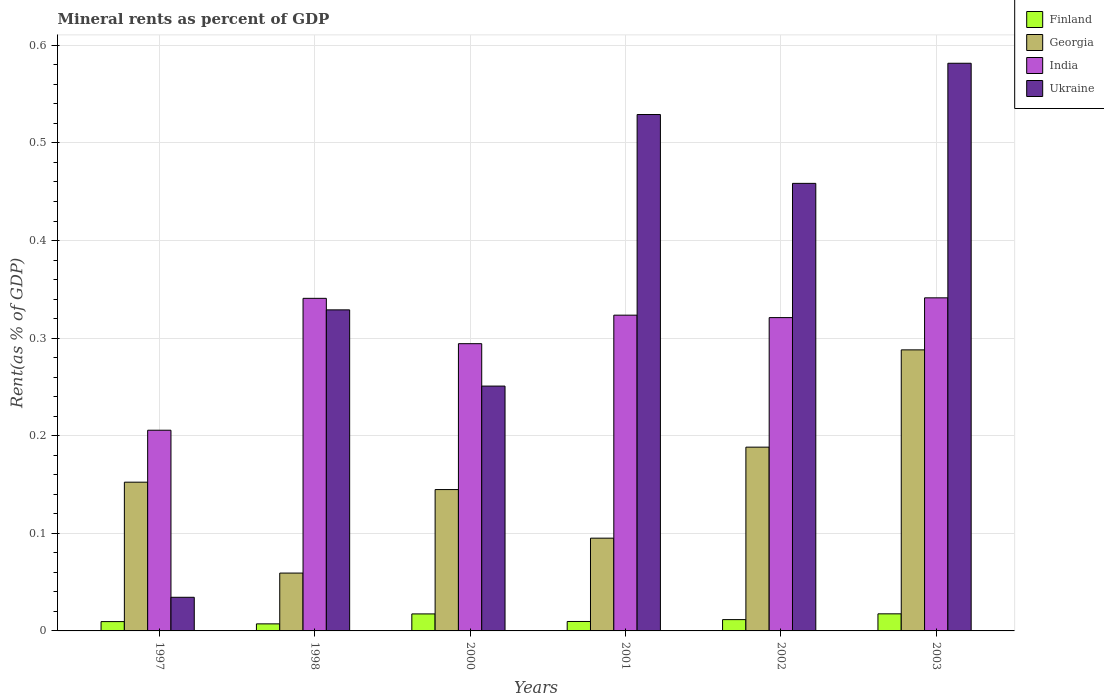How many different coloured bars are there?
Offer a very short reply. 4. How many groups of bars are there?
Give a very brief answer. 6. Are the number of bars per tick equal to the number of legend labels?
Give a very brief answer. Yes. Are the number of bars on each tick of the X-axis equal?
Offer a terse response. Yes. How many bars are there on the 1st tick from the right?
Offer a very short reply. 4. What is the label of the 6th group of bars from the left?
Provide a short and direct response. 2003. In how many cases, is the number of bars for a given year not equal to the number of legend labels?
Provide a short and direct response. 0. What is the mineral rent in Ukraine in 2001?
Your answer should be very brief. 0.53. Across all years, what is the maximum mineral rent in Finland?
Your response must be concise. 0.02. Across all years, what is the minimum mineral rent in Finland?
Your answer should be very brief. 0.01. In which year was the mineral rent in Georgia minimum?
Make the answer very short. 1998. What is the total mineral rent in Georgia in the graph?
Keep it short and to the point. 0.93. What is the difference between the mineral rent in Finland in 2000 and that in 2003?
Your answer should be very brief. -7.728622629299756e-5. What is the difference between the mineral rent in India in 1997 and the mineral rent in Finland in 2001?
Offer a terse response. 0.2. What is the average mineral rent in Georgia per year?
Give a very brief answer. 0.15. In the year 2001, what is the difference between the mineral rent in India and mineral rent in Georgia?
Offer a terse response. 0.23. What is the ratio of the mineral rent in India in 1998 to that in 2001?
Provide a succinct answer. 1.05. What is the difference between the highest and the second highest mineral rent in Georgia?
Offer a very short reply. 0.1. What is the difference between the highest and the lowest mineral rent in Georgia?
Offer a terse response. 0.23. In how many years, is the mineral rent in India greater than the average mineral rent in India taken over all years?
Give a very brief answer. 4. Is it the case that in every year, the sum of the mineral rent in Georgia and mineral rent in Ukraine is greater than the sum of mineral rent in Finland and mineral rent in India?
Your response must be concise. No. What does the 4th bar from the left in 2000 represents?
Your answer should be very brief. Ukraine. What does the 1st bar from the right in 2002 represents?
Provide a short and direct response. Ukraine. Is it the case that in every year, the sum of the mineral rent in Ukraine and mineral rent in Finland is greater than the mineral rent in India?
Your response must be concise. No. How many bars are there?
Make the answer very short. 24. How many years are there in the graph?
Provide a succinct answer. 6. Does the graph contain any zero values?
Offer a terse response. No. Where does the legend appear in the graph?
Offer a very short reply. Top right. How many legend labels are there?
Your answer should be very brief. 4. What is the title of the graph?
Your response must be concise. Mineral rents as percent of GDP. Does "Angola" appear as one of the legend labels in the graph?
Offer a very short reply. No. What is the label or title of the Y-axis?
Give a very brief answer. Rent(as % of GDP). What is the Rent(as % of GDP) of Finland in 1997?
Ensure brevity in your answer.  0.01. What is the Rent(as % of GDP) of Georgia in 1997?
Provide a succinct answer. 0.15. What is the Rent(as % of GDP) in India in 1997?
Provide a short and direct response. 0.21. What is the Rent(as % of GDP) in Ukraine in 1997?
Offer a very short reply. 0.03. What is the Rent(as % of GDP) in Finland in 1998?
Ensure brevity in your answer.  0.01. What is the Rent(as % of GDP) in Georgia in 1998?
Keep it short and to the point. 0.06. What is the Rent(as % of GDP) of India in 1998?
Provide a short and direct response. 0.34. What is the Rent(as % of GDP) in Ukraine in 1998?
Give a very brief answer. 0.33. What is the Rent(as % of GDP) in Finland in 2000?
Provide a succinct answer. 0.02. What is the Rent(as % of GDP) of Georgia in 2000?
Offer a terse response. 0.14. What is the Rent(as % of GDP) in India in 2000?
Offer a very short reply. 0.29. What is the Rent(as % of GDP) in Ukraine in 2000?
Offer a terse response. 0.25. What is the Rent(as % of GDP) in Finland in 2001?
Ensure brevity in your answer.  0.01. What is the Rent(as % of GDP) of Georgia in 2001?
Make the answer very short. 0.1. What is the Rent(as % of GDP) of India in 2001?
Your response must be concise. 0.32. What is the Rent(as % of GDP) of Ukraine in 2001?
Offer a very short reply. 0.53. What is the Rent(as % of GDP) in Finland in 2002?
Provide a short and direct response. 0.01. What is the Rent(as % of GDP) in Georgia in 2002?
Ensure brevity in your answer.  0.19. What is the Rent(as % of GDP) of India in 2002?
Give a very brief answer. 0.32. What is the Rent(as % of GDP) of Ukraine in 2002?
Your answer should be very brief. 0.46. What is the Rent(as % of GDP) of Finland in 2003?
Provide a succinct answer. 0.02. What is the Rent(as % of GDP) of Georgia in 2003?
Offer a terse response. 0.29. What is the Rent(as % of GDP) in India in 2003?
Provide a short and direct response. 0.34. What is the Rent(as % of GDP) in Ukraine in 2003?
Ensure brevity in your answer.  0.58. Across all years, what is the maximum Rent(as % of GDP) of Finland?
Provide a short and direct response. 0.02. Across all years, what is the maximum Rent(as % of GDP) of Georgia?
Make the answer very short. 0.29. Across all years, what is the maximum Rent(as % of GDP) of India?
Provide a short and direct response. 0.34. Across all years, what is the maximum Rent(as % of GDP) of Ukraine?
Offer a very short reply. 0.58. Across all years, what is the minimum Rent(as % of GDP) of Finland?
Provide a short and direct response. 0.01. Across all years, what is the minimum Rent(as % of GDP) of Georgia?
Your response must be concise. 0.06. Across all years, what is the minimum Rent(as % of GDP) of India?
Keep it short and to the point. 0.21. Across all years, what is the minimum Rent(as % of GDP) in Ukraine?
Keep it short and to the point. 0.03. What is the total Rent(as % of GDP) in Finland in the graph?
Ensure brevity in your answer.  0.07. What is the total Rent(as % of GDP) of Georgia in the graph?
Give a very brief answer. 0.93. What is the total Rent(as % of GDP) of India in the graph?
Your response must be concise. 1.83. What is the total Rent(as % of GDP) of Ukraine in the graph?
Ensure brevity in your answer.  2.18. What is the difference between the Rent(as % of GDP) of Finland in 1997 and that in 1998?
Offer a terse response. 0. What is the difference between the Rent(as % of GDP) of Georgia in 1997 and that in 1998?
Offer a very short reply. 0.09. What is the difference between the Rent(as % of GDP) in India in 1997 and that in 1998?
Your answer should be very brief. -0.14. What is the difference between the Rent(as % of GDP) of Ukraine in 1997 and that in 1998?
Give a very brief answer. -0.29. What is the difference between the Rent(as % of GDP) in Finland in 1997 and that in 2000?
Your answer should be very brief. -0.01. What is the difference between the Rent(as % of GDP) of Georgia in 1997 and that in 2000?
Your answer should be very brief. 0.01. What is the difference between the Rent(as % of GDP) of India in 1997 and that in 2000?
Ensure brevity in your answer.  -0.09. What is the difference between the Rent(as % of GDP) in Ukraine in 1997 and that in 2000?
Provide a short and direct response. -0.22. What is the difference between the Rent(as % of GDP) of Finland in 1997 and that in 2001?
Offer a very short reply. -0. What is the difference between the Rent(as % of GDP) of Georgia in 1997 and that in 2001?
Provide a short and direct response. 0.06. What is the difference between the Rent(as % of GDP) in India in 1997 and that in 2001?
Make the answer very short. -0.12. What is the difference between the Rent(as % of GDP) in Ukraine in 1997 and that in 2001?
Give a very brief answer. -0.49. What is the difference between the Rent(as % of GDP) in Finland in 1997 and that in 2002?
Your answer should be very brief. -0. What is the difference between the Rent(as % of GDP) of Georgia in 1997 and that in 2002?
Ensure brevity in your answer.  -0.04. What is the difference between the Rent(as % of GDP) in India in 1997 and that in 2002?
Offer a very short reply. -0.12. What is the difference between the Rent(as % of GDP) of Ukraine in 1997 and that in 2002?
Your answer should be very brief. -0.42. What is the difference between the Rent(as % of GDP) in Finland in 1997 and that in 2003?
Your answer should be compact. -0.01. What is the difference between the Rent(as % of GDP) of Georgia in 1997 and that in 2003?
Your response must be concise. -0.14. What is the difference between the Rent(as % of GDP) of India in 1997 and that in 2003?
Your answer should be compact. -0.14. What is the difference between the Rent(as % of GDP) in Ukraine in 1997 and that in 2003?
Offer a very short reply. -0.55. What is the difference between the Rent(as % of GDP) in Finland in 1998 and that in 2000?
Your response must be concise. -0.01. What is the difference between the Rent(as % of GDP) of Georgia in 1998 and that in 2000?
Your answer should be very brief. -0.09. What is the difference between the Rent(as % of GDP) in India in 1998 and that in 2000?
Your response must be concise. 0.05. What is the difference between the Rent(as % of GDP) in Ukraine in 1998 and that in 2000?
Your response must be concise. 0.08. What is the difference between the Rent(as % of GDP) in Finland in 1998 and that in 2001?
Ensure brevity in your answer.  -0. What is the difference between the Rent(as % of GDP) of Georgia in 1998 and that in 2001?
Provide a succinct answer. -0.04. What is the difference between the Rent(as % of GDP) in India in 1998 and that in 2001?
Provide a succinct answer. 0.02. What is the difference between the Rent(as % of GDP) of Ukraine in 1998 and that in 2001?
Your answer should be compact. -0.2. What is the difference between the Rent(as % of GDP) in Finland in 1998 and that in 2002?
Offer a terse response. -0. What is the difference between the Rent(as % of GDP) in Georgia in 1998 and that in 2002?
Provide a short and direct response. -0.13. What is the difference between the Rent(as % of GDP) of India in 1998 and that in 2002?
Your answer should be compact. 0.02. What is the difference between the Rent(as % of GDP) of Ukraine in 1998 and that in 2002?
Ensure brevity in your answer.  -0.13. What is the difference between the Rent(as % of GDP) in Finland in 1998 and that in 2003?
Keep it short and to the point. -0.01. What is the difference between the Rent(as % of GDP) in Georgia in 1998 and that in 2003?
Your response must be concise. -0.23. What is the difference between the Rent(as % of GDP) of India in 1998 and that in 2003?
Ensure brevity in your answer.  -0. What is the difference between the Rent(as % of GDP) of Ukraine in 1998 and that in 2003?
Ensure brevity in your answer.  -0.25. What is the difference between the Rent(as % of GDP) of Finland in 2000 and that in 2001?
Your answer should be compact. 0.01. What is the difference between the Rent(as % of GDP) of Georgia in 2000 and that in 2001?
Provide a short and direct response. 0.05. What is the difference between the Rent(as % of GDP) in India in 2000 and that in 2001?
Your answer should be very brief. -0.03. What is the difference between the Rent(as % of GDP) of Ukraine in 2000 and that in 2001?
Your response must be concise. -0.28. What is the difference between the Rent(as % of GDP) of Finland in 2000 and that in 2002?
Your answer should be very brief. 0.01. What is the difference between the Rent(as % of GDP) in Georgia in 2000 and that in 2002?
Keep it short and to the point. -0.04. What is the difference between the Rent(as % of GDP) in India in 2000 and that in 2002?
Keep it short and to the point. -0.03. What is the difference between the Rent(as % of GDP) in Ukraine in 2000 and that in 2002?
Your answer should be very brief. -0.21. What is the difference between the Rent(as % of GDP) in Finland in 2000 and that in 2003?
Keep it short and to the point. -0. What is the difference between the Rent(as % of GDP) in Georgia in 2000 and that in 2003?
Give a very brief answer. -0.14. What is the difference between the Rent(as % of GDP) of India in 2000 and that in 2003?
Provide a succinct answer. -0.05. What is the difference between the Rent(as % of GDP) in Ukraine in 2000 and that in 2003?
Make the answer very short. -0.33. What is the difference between the Rent(as % of GDP) of Finland in 2001 and that in 2002?
Give a very brief answer. -0. What is the difference between the Rent(as % of GDP) in Georgia in 2001 and that in 2002?
Provide a short and direct response. -0.09. What is the difference between the Rent(as % of GDP) in India in 2001 and that in 2002?
Give a very brief answer. 0. What is the difference between the Rent(as % of GDP) of Ukraine in 2001 and that in 2002?
Your answer should be compact. 0.07. What is the difference between the Rent(as % of GDP) in Finland in 2001 and that in 2003?
Provide a short and direct response. -0.01. What is the difference between the Rent(as % of GDP) in Georgia in 2001 and that in 2003?
Keep it short and to the point. -0.19. What is the difference between the Rent(as % of GDP) of India in 2001 and that in 2003?
Your answer should be compact. -0.02. What is the difference between the Rent(as % of GDP) of Ukraine in 2001 and that in 2003?
Offer a terse response. -0.05. What is the difference between the Rent(as % of GDP) in Finland in 2002 and that in 2003?
Your answer should be compact. -0.01. What is the difference between the Rent(as % of GDP) of Georgia in 2002 and that in 2003?
Offer a very short reply. -0.1. What is the difference between the Rent(as % of GDP) in India in 2002 and that in 2003?
Your answer should be very brief. -0.02. What is the difference between the Rent(as % of GDP) in Ukraine in 2002 and that in 2003?
Your response must be concise. -0.12. What is the difference between the Rent(as % of GDP) in Finland in 1997 and the Rent(as % of GDP) in Georgia in 1998?
Make the answer very short. -0.05. What is the difference between the Rent(as % of GDP) in Finland in 1997 and the Rent(as % of GDP) in India in 1998?
Give a very brief answer. -0.33. What is the difference between the Rent(as % of GDP) of Finland in 1997 and the Rent(as % of GDP) of Ukraine in 1998?
Offer a terse response. -0.32. What is the difference between the Rent(as % of GDP) in Georgia in 1997 and the Rent(as % of GDP) in India in 1998?
Give a very brief answer. -0.19. What is the difference between the Rent(as % of GDP) in Georgia in 1997 and the Rent(as % of GDP) in Ukraine in 1998?
Your answer should be very brief. -0.18. What is the difference between the Rent(as % of GDP) of India in 1997 and the Rent(as % of GDP) of Ukraine in 1998?
Provide a succinct answer. -0.12. What is the difference between the Rent(as % of GDP) of Finland in 1997 and the Rent(as % of GDP) of Georgia in 2000?
Give a very brief answer. -0.14. What is the difference between the Rent(as % of GDP) of Finland in 1997 and the Rent(as % of GDP) of India in 2000?
Provide a short and direct response. -0.28. What is the difference between the Rent(as % of GDP) of Finland in 1997 and the Rent(as % of GDP) of Ukraine in 2000?
Offer a terse response. -0.24. What is the difference between the Rent(as % of GDP) in Georgia in 1997 and the Rent(as % of GDP) in India in 2000?
Provide a succinct answer. -0.14. What is the difference between the Rent(as % of GDP) in Georgia in 1997 and the Rent(as % of GDP) in Ukraine in 2000?
Your answer should be very brief. -0.1. What is the difference between the Rent(as % of GDP) in India in 1997 and the Rent(as % of GDP) in Ukraine in 2000?
Keep it short and to the point. -0.05. What is the difference between the Rent(as % of GDP) of Finland in 1997 and the Rent(as % of GDP) of Georgia in 2001?
Provide a short and direct response. -0.09. What is the difference between the Rent(as % of GDP) of Finland in 1997 and the Rent(as % of GDP) of India in 2001?
Offer a terse response. -0.31. What is the difference between the Rent(as % of GDP) in Finland in 1997 and the Rent(as % of GDP) in Ukraine in 2001?
Your response must be concise. -0.52. What is the difference between the Rent(as % of GDP) in Georgia in 1997 and the Rent(as % of GDP) in India in 2001?
Your answer should be compact. -0.17. What is the difference between the Rent(as % of GDP) in Georgia in 1997 and the Rent(as % of GDP) in Ukraine in 2001?
Ensure brevity in your answer.  -0.38. What is the difference between the Rent(as % of GDP) of India in 1997 and the Rent(as % of GDP) of Ukraine in 2001?
Your response must be concise. -0.32. What is the difference between the Rent(as % of GDP) of Finland in 1997 and the Rent(as % of GDP) of Georgia in 2002?
Offer a terse response. -0.18. What is the difference between the Rent(as % of GDP) in Finland in 1997 and the Rent(as % of GDP) in India in 2002?
Your answer should be compact. -0.31. What is the difference between the Rent(as % of GDP) of Finland in 1997 and the Rent(as % of GDP) of Ukraine in 2002?
Make the answer very short. -0.45. What is the difference between the Rent(as % of GDP) of Georgia in 1997 and the Rent(as % of GDP) of India in 2002?
Make the answer very short. -0.17. What is the difference between the Rent(as % of GDP) in Georgia in 1997 and the Rent(as % of GDP) in Ukraine in 2002?
Offer a terse response. -0.31. What is the difference between the Rent(as % of GDP) in India in 1997 and the Rent(as % of GDP) in Ukraine in 2002?
Provide a short and direct response. -0.25. What is the difference between the Rent(as % of GDP) in Finland in 1997 and the Rent(as % of GDP) in Georgia in 2003?
Your response must be concise. -0.28. What is the difference between the Rent(as % of GDP) of Finland in 1997 and the Rent(as % of GDP) of India in 2003?
Ensure brevity in your answer.  -0.33. What is the difference between the Rent(as % of GDP) in Finland in 1997 and the Rent(as % of GDP) in Ukraine in 2003?
Keep it short and to the point. -0.57. What is the difference between the Rent(as % of GDP) of Georgia in 1997 and the Rent(as % of GDP) of India in 2003?
Ensure brevity in your answer.  -0.19. What is the difference between the Rent(as % of GDP) of Georgia in 1997 and the Rent(as % of GDP) of Ukraine in 2003?
Make the answer very short. -0.43. What is the difference between the Rent(as % of GDP) in India in 1997 and the Rent(as % of GDP) in Ukraine in 2003?
Make the answer very short. -0.38. What is the difference between the Rent(as % of GDP) of Finland in 1998 and the Rent(as % of GDP) of Georgia in 2000?
Offer a terse response. -0.14. What is the difference between the Rent(as % of GDP) in Finland in 1998 and the Rent(as % of GDP) in India in 2000?
Provide a succinct answer. -0.29. What is the difference between the Rent(as % of GDP) in Finland in 1998 and the Rent(as % of GDP) in Ukraine in 2000?
Make the answer very short. -0.24. What is the difference between the Rent(as % of GDP) in Georgia in 1998 and the Rent(as % of GDP) in India in 2000?
Offer a terse response. -0.23. What is the difference between the Rent(as % of GDP) of Georgia in 1998 and the Rent(as % of GDP) of Ukraine in 2000?
Your answer should be compact. -0.19. What is the difference between the Rent(as % of GDP) in India in 1998 and the Rent(as % of GDP) in Ukraine in 2000?
Your answer should be compact. 0.09. What is the difference between the Rent(as % of GDP) of Finland in 1998 and the Rent(as % of GDP) of Georgia in 2001?
Your response must be concise. -0.09. What is the difference between the Rent(as % of GDP) in Finland in 1998 and the Rent(as % of GDP) in India in 2001?
Provide a succinct answer. -0.32. What is the difference between the Rent(as % of GDP) in Finland in 1998 and the Rent(as % of GDP) in Ukraine in 2001?
Your response must be concise. -0.52. What is the difference between the Rent(as % of GDP) in Georgia in 1998 and the Rent(as % of GDP) in India in 2001?
Ensure brevity in your answer.  -0.26. What is the difference between the Rent(as % of GDP) of Georgia in 1998 and the Rent(as % of GDP) of Ukraine in 2001?
Offer a very short reply. -0.47. What is the difference between the Rent(as % of GDP) of India in 1998 and the Rent(as % of GDP) of Ukraine in 2001?
Offer a very short reply. -0.19. What is the difference between the Rent(as % of GDP) of Finland in 1998 and the Rent(as % of GDP) of Georgia in 2002?
Your response must be concise. -0.18. What is the difference between the Rent(as % of GDP) in Finland in 1998 and the Rent(as % of GDP) in India in 2002?
Your answer should be very brief. -0.31. What is the difference between the Rent(as % of GDP) in Finland in 1998 and the Rent(as % of GDP) in Ukraine in 2002?
Provide a short and direct response. -0.45. What is the difference between the Rent(as % of GDP) of Georgia in 1998 and the Rent(as % of GDP) of India in 2002?
Your answer should be very brief. -0.26. What is the difference between the Rent(as % of GDP) of Georgia in 1998 and the Rent(as % of GDP) of Ukraine in 2002?
Provide a succinct answer. -0.4. What is the difference between the Rent(as % of GDP) of India in 1998 and the Rent(as % of GDP) of Ukraine in 2002?
Your answer should be very brief. -0.12. What is the difference between the Rent(as % of GDP) in Finland in 1998 and the Rent(as % of GDP) in Georgia in 2003?
Ensure brevity in your answer.  -0.28. What is the difference between the Rent(as % of GDP) in Finland in 1998 and the Rent(as % of GDP) in India in 2003?
Provide a succinct answer. -0.33. What is the difference between the Rent(as % of GDP) in Finland in 1998 and the Rent(as % of GDP) in Ukraine in 2003?
Offer a terse response. -0.57. What is the difference between the Rent(as % of GDP) in Georgia in 1998 and the Rent(as % of GDP) in India in 2003?
Provide a short and direct response. -0.28. What is the difference between the Rent(as % of GDP) in Georgia in 1998 and the Rent(as % of GDP) in Ukraine in 2003?
Your answer should be compact. -0.52. What is the difference between the Rent(as % of GDP) of India in 1998 and the Rent(as % of GDP) of Ukraine in 2003?
Ensure brevity in your answer.  -0.24. What is the difference between the Rent(as % of GDP) of Finland in 2000 and the Rent(as % of GDP) of Georgia in 2001?
Provide a short and direct response. -0.08. What is the difference between the Rent(as % of GDP) of Finland in 2000 and the Rent(as % of GDP) of India in 2001?
Your answer should be compact. -0.31. What is the difference between the Rent(as % of GDP) of Finland in 2000 and the Rent(as % of GDP) of Ukraine in 2001?
Offer a terse response. -0.51. What is the difference between the Rent(as % of GDP) of Georgia in 2000 and the Rent(as % of GDP) of India in 2001?
Your answer should be very brief. -0.18. What is the difference between the Rent(as % of GDP) in Georgia in 2000 and the Rent(as % of GDP) in Ukraine in 2001?
Offer a terse response. -0.38. What is the difference between the Rent(as % of GDP) of India in 2000 and the Rent(as % of GDP) of Ukraine in 2001?
Your answer should be very brief. -0.23. What is the difference between the Rent(as % of GDP) of Finland in 2000 and the Rent(as % of GDP) of Georgia in 2002?
Your answer should be very brief. -0.17. What is the difference between the Rent(as % of GDP) of Finland in 2000 and the Rent(as % of GDP) of India in 2002?
Your answer should be very brief. -0.3. What is the difference between the Rent(as % of GDP) of Finland in 2000 and the Rent(as % of GDP) of Ukraine in 2002?
Offer a terse response. -0.44. What is the difference between the Rent(as % of GDP) of Georgia in 2000 and the Rent(as % of GDP) of India in 2002?
Ensure brevity in your answer.  -0.18. What is the difference between the Rent(as % of GDP) in Georgia in 2000 and the Rent(as % of GDP) in Ukraine in 2002?
Give a very brief answer. -0.31. What is the difference between the Rent(as % of GDP) of India in 2000 and the Rent(as % of GDP) of Ukraine in 2002?
Ensure brevity in your answer.  -0.16. What is the difference between the Rent(as % of GDP) of Finland in 2000 and the Rent(as % of GDP) of Georgia in 2003?
Give a very brief answer. -0.27. What is the difference between the Rent(as % of GDP) of Finland in 2000 and the Rent(as % of GDP) of India in 2003?
Offer a terse response. -0.32. What is the difference between the Rent(as % of GDP) of Finland in 2000 and the Rent(as % of GDP) of Ukraine in 2003?
Your answer should be compact. -0.56. What is the difference between the Rent(as % of GDP) in Georgia in 2000 and the Rent(as % of GDP) in India in 2003?
Offer a very short reply. -0.2. What is the difference between the Rent(as % of GDP) in Georgia in 2000 and the Rent(as % of GDP) in Ukraine in 2003?
Your response must be concise. -0.44. What is the difference between the Rent(as % of GDP) in India in 2000 and the Rent(as % of GDP) in Ukraine in 2003?
Provide a short and direct response. -0.29. What is the difference between the Rent(as % of GDP) of Finland in 2001 and the Rent(as % of GDP) of Georgia in 2002?
Ensure brevity in your answer.  -0.18. What is the difference between the Rent(as % of GDP) of Finland in 2001 and the Rent(as % of GDP) of India in 2002?
Ensure brevity in your answer.  -0.31. What is the difference between the Rent(as % of GDP) in Finland in 2001 and the Rent(as % of GDP) in Ukraine in 2002?
Ensure brevity in your answer.  -0.45. What is the difference between the Rent(as % of GDP) of Georgia in 2001 and the Rent(as % of GDP) of India in 2002?
Ensure brevity in your answer.  -0.23. What is the difference between the Rent(as % of GDP) in Georgia in 2001 and the Rent(as % of GDP) in Ukraine in 2002?
Offer a very short reply. -0.36. What is the difference between the Rent(as % of GDP) in India in 2001 and the Rent(as % of GDP) in Ukraine in 2002?
Provide a succinct answer. -0.14. What is the difference between the Rent(as % of GDP) of Finland in 2001 and the Rent(as % of GDP) of Georgia in 2003?
Ensure brevity in your answer.  -0.28. What is the difference between the Rent(as % of GDP) in Finland in 2001 and the Rent(as % of GDP) in India in 2003?
Ensure brevity in your answer.  -0.33. What is the difference between the Rent(as % of GDP) of Finland in 2001 and the Rent(as % of GDP) of Ukraine in 2003?
Give a very brief answer. -0.57. What is the difference between the Rent(as % of GDP) in Georgia in 2001 and the Rent(as % of GDP) in India in 2003?
Your answer should be very brief. -0.25. What is the difference between the Rent(as % of GDP) of Georgia in 2001 and the Rent(as % of GDP) of Ukraine in 2003?
Give a very brief answer. -0.49. What is the difference between the Rent(as % of GDP) in India in 2001 and the Rent(as % of GDP) in Ukraine in 2003?
Your response must be concise. -0.26. What is the difference between the Rent(as % of GDP) of Finland in 2002 and the Rent(as % of GDP) of Georgia in 2003?
Provide a short and direct response. -0.28. What is the difference between the Rent(as % of GDP) of Finland in 2002 and the Rent(as % of GDP) of India in 2003?
Offer a terse response. -0.33. What is the difference between the Rent(as % of GDP) of Finland in 2002 and the Rent(as % of GDP) of Ukraine in 2003?
Make the answer very short. -0.57. What is the difference between the Rent(as % of GDP) in Georgia in 2002 and the Rent(as % of GDP) in India in 2003?
Provide a short and direct response. -0.15. What is the difference between the Rent(as % of GDP) of Georgia in 2002 and the Rent(as % of GDP) of Ukraine in 2003?
Keep it short and to the point. -0.39. What is the difference between the Rent(as % of GDP) in India in 2002 and the Rent(as % of GDP) in Ukraine in 2003?
Offer a terse response. -0.26. What is the average Rent(as % of GDP) of Finland per year?
Give a very brief answer. 0.01. What is the average Rent(as % of GDP) of Georgia per year?
Offer a very short reply. 0.15. What is the average Rent(as % of GDP) of India per year?
Make the answer very short. 0.3. What is the average Rent(as % of GDP) of Ukraine per year?
Keep it short and to the point. 0.36. In the year 1997, what is the difference between the Rent(as % of GDP) in Finland and Rent(as % of GDP) in Georgia?
Offer a terse response. -0.14. In the year 1997, what is the difference between the Rent(as % of GDP) in Finland and Rent(as % of GDP) in India?
Offer a terse response. -0.2. In the year 1997, what is the difference between the Rent(as % of GDP) of Finland and Rent(as % of GDP) of Ukraine?
Provide a succinct answer. -0.02. In the year 1997, what is the difference between the Rent(as % of GDP) of Georgia and Rent(as % of GDP) of India?
Your response must be concise. -0.05. In the year 1997, what is the difference between the Rent(as % of GDP) of Georgia and Rent(as % of GDP) of Ukraine?
Ensure brevity in your answer.  0.12. In the year 1997, what is the difference between the Rent(as % of GDP) in India and Rent(as % of GDP) in Ukraine?
Provide a short and direct response. 0.17. In the year 1998, what is the difference between the Rent(as % of GDP) of Finland and Rent(as % of GDP) of Georgia?
Provide a short and direct response. -0.05. In the year 1998, what is the difference between the Rent(as % of GDP) of Finland and Rent(as % of GDP) of India?
Make the answer very short. -0.33. In the year 1998, what is the difference between the Rent(as % of GDP) of Finland and Rent(as % of GDP) of Ukraine?
Your answer should be very brief. -0.32. In the year 1998, what is the difference between the Rent(as % of GDP) in Georgia and Rent(as % of GDP) in India?
Provide a short and direct response. -0.28. In the year 1998, what is the difference between the Rent(as % of GDP) of Georgia and Rent(as % of GDP) of Ukraine?
Offer a terse response. -0.27. In the year 1998, what is the difference between the Rent(as % of GDP) of India and Rent(as % of GDP) of Ukraine?
Ensure brevity in your answer.  0.01. In the year 2000, what is the difference between the Rent(as % of GDP) of Finland and Rent(as % of GDP) of Georgia?
Make the answer very short. -0.13. In the year 2000, what is the difference between the Rent(as % of GDP) in Finland and Rent(as % of GDP) in India?
Your answer should be compact. -0.28. In the year 2000, what is the difference between the Rent(as % of GDP) of Finland and Rent(as % of GDP) of Ukraine?
Offer a very short reply. -0.23. In the year 2000, what is the difference between the Rent(as % of GDP) in Georgia and Rent(as % of GDP) in India?
Provide a short and direct response. -0.15. In the year 2000, what is the difference between the Rent(as % of GDP) in Georgia and Rent(as % of GDP) in Ukraine?
Give a very brief answer. -0.11. In the year 2000, what is the difference between the Rent(as % of GDP) in India and Rent(as % of GDP) in Ukraine?
Provide a short and direct response. 0.04. In the year 2001, what is the difference between the Rent(as % of GDP) of Finland and Rent(as % of GDP) of Georgia?
Offer a terse response. -0.09. In the year 2001, what is the difference between the Rent(as % of GDP) of Finland and Rent(as % of GDP) of India?
Give a very brief answer. -0.31. In the year 2001, what is the difference between the Rent(as % of GDP) of Finland and Rent(as % of GDP) of Ukraine?
Make the answer very short. -0.52. In the year 2001, what is the difference between the Rent(as % of GDP) of Georgia and Rent(as % of GDP) of India?
Provide a succinct answer. -0.23. In the year 2001, what is the difference between the Rent(as % of GDP) in Georgia and Rent(as % of GDP) in Ukraine?
Your answer should be very brief. -0.43. In the year 2001, what is the difference between the Rent(as % of GDP) of India and Rent(as % of GDP) of Ukraine?
Your answer should be very brief. -0.21. In the year 2002, what is the difference between the Rent(as % of GDP) of Finland and Rent(as % of GDP) of Georgia?
Your answer should be very brief. -0.18. In the year 2002, what is the difference between the Rent(as % of GDP) in Finland and Rent(as % of GDP) in India?
Your answer should be compact. -0.31. In the year 2002, what is the difference between the Rent(as % of GDP) in Finland and Rent(as % of GDP) in Ukraine?
Provide a short and direct response. -0.45. In the year 2002, what is the difference between the Rent(as % of GDP) of Georgia and Rent(as % of GDP) of India?
Keep it short and to the point. -0.13. In the year 2002, what is the difference between the Rent(as % of GDP) in Georgia and Rent(as % of GDP) in Ukraine?
Offer a terse response. -0.27. In the year 2002, what is the difference between the Rent(as % of GDP) of India and Rent(as % of GDP) of Ukraine?
Your answer should be compact. -0.14. In the year 2003, what is the difference between the Rent(as % of GDP) of Finland and Rent(as % of GDP) of Georgia?
Make the answer very short. -0.27. In the year 2003, what is the difference between the Rent(as % of GDP) in Finland and Rent(as % of GDP) in India?
Your answer should be compact. -0.32. In the year 2003, what is the difference between the Rent(as % of GDP) in Finland and Rent(as % of GDP) in Ukraine?
Keep it short and to the point. -0.56. In the year 2003, what is the difference between the Rent(as % of GDP) of Georgia and Rent(as % of GDP) of India?
Give a very brief answer. -0.05. In the year 2003, what is the difference between the Rent(as % of GDP) of Georgia and Rent(as % of GDP) of Ukraine?
Provide a short and direct response. -0.29. In the year 2003, what is the difference between the Rent(as % of GDP) in India and Rent(as % of GDP) in Ukraine?
Your answer should be compact. -0.24. What is the ratio of the Rent(as % of GDP) in Finland in 1997 to that in 1998?
Offer a very short reply. 1.32. What is the ratio of the Rent(as % of GDP) in Georgia in 1997 to that in 1998?
Give a very brief answer. 2.57. What is the ratio of the Rent(as % of GDP) in India in 1997 to that in 1998?
Provide a short and direct response. 0.6. What is the ratio of the Rent(as % of GDP) of Ukraine in 1997 to that in 1998?
Provide a short and direct response. 0.1. What is the ratio of the Rent(as % of GDP) in Finland in 1997 to that in 2000?
Offer a very short reply. 0.55. What is the ratio of the Rent(as % of GDP) in Georgia in 1997 to that in 2000?
Provide a short and direct response. 1.05. What is the ratio of the Rent(as % of GDP) of India in 1997 to that in 2000?
Give a very brief answer. 0.7. What is the ratio of the Rent(as % of GDP) in Ukraine in 1997 to that in 2000?
Make the answer very short. 0.14. What is the ratio of the Rent(as % of GDP) of Finland in 1997 to that in 2001?
Provide a short and direct response. 0.99. What is the ratio of the Rent(as % of GDP) of Georgia in 1997 to that in 2001?
Offer a terse response. 1.6. What is the ratio of the Rent(as % of GDP) in India in 1997 to that in 2001?
Offer a terse response. 0.64. What is the ratio of the Rent(as % of GDP) in Ukraine in 1997 to that in 2001?
Provide a succinct answer. 0.07. What is the ratio of the Rent(as % of GDP) in Finland in 1997 to that in 2002?
Keep it short and to the point. 0.82. What is the ratio of the Rent(as % of GDP) in Georgia in 1997 to that in 2002?
Offer a terse response. 0.81. What is the ratio of the Rent(as % of GDP) of India in 1997 to that in 2002?
Provide a succinct answer. 0.64. What is the ratio of the Rent(as % of GDP) in Ukraine in 1997 to that in 2002?
Your response must be concise. 0.08. What is the ratio of the Rent(as % of GDP) of Finland in 1997 to that in 2003?
Make the answer very short. 0.55. What is the ratio of the Rent(as % of GDP) of Georgia in 1997 to that in 2003?
Provide a succinct answer. 0.53. What is the ratio of the Rent(as % of GDP) of India in 1997 to that in 2003?
Your answer should be very brief. 0.6. What is the ratio of the Rent(as % of GDP) of Ukraine in 1997 to that in 2003?
Keep it short and to the point. 0.06. What is the ratio of the Rent(as % of GDP) in Finland in 1998 to that in 2000?
Give a very brief answer. 0.41. What is the ratio of the Rent(as % of GDP) in Georgia in 1998 to that in 2000?
Keep it short and to the point. 0.41. What is the ratio of the Rent(as % of GDP) of India in 1998 to that in 2000?
Your response must be concise. 1.16. What is the ratio of the Rent(as % of GDP) of Ukraine in 1998 to that in 2000?
Keep it short and to the point. 1.31. What is the ratio of the Rent(as % of GDP) in Finland in 1998 to that in 2001?
Your answer should be very brief. 0.75. What is the ratio of the Rent(as % of GDP) in Georgia in 1998 to that in 2001?
Keep it short and to the point. 0.62. What is the ratio of the Rent(as % of GDP) of India in 1998 to that in 2001?
Your answer should be very brief. 1.05. What is the ratio of the Rent(as % of GDP) of Ukraine in 1998 to that in 2001?
Ensure brevity in your answer.  0.62. What is the ratio of the Rent(as % of GDP) of Finland in 1998 to that in 2002?
Ensure brevity in your answer.  0.62. What is the ratio of the Rent(as % of GDP) in Georgia in 1998 to that in 2002?
Ensure brevity in your answer.  0.31. What is the ratio of the Rent(as % of GDP) in India in 1998 to that in 2002?
Give a very brief answer. 1.06. What is the ratio of the Rent(as % of GDP) in Ukraine in 1998 to that in 2002?
Your answer should be very brief. 0.72. What is the ratio of the Rent(as % of GDP) of Finland in 1998 to that in 2003?
Provide a short and direct response. 0.41. What is the ratio of the Rent(as % of GDP) of Georgia in 1998 to that in 2003?
Your response must be concise. 0.21. What is the ratio of the Rent(as % of GDP) in Ukraine in 1998 to that in 2003?
Your answer should be very brief. 0.57. What is the ratio of the Rent(as % of GDP) in Finland in 2000 to that in 2001?
Your answer should be compact. 1.8. What is the ratio of the Rent(as % of GDP) of Georgia in 2000 to that in 2001?
Give a very brief answer. 1.52. What is the ratio of the Rent(as % of GDP) in India in 2000 to that in 2001?
Ensure brevity in your answer.  0.91. What is the ratio of the Rent(as % of GDP) in Ukraine in 2000 to that in 2001?
Ensure brevity in your answer.  0.47. What is the ratio of the Rent(as % of GDP) of Finland in 2000 to that in 2002?
Your response must be concise. 1.5. What is the ratio of the Rent(as % of GDP) of Georgia in 2000 to that in 2002?
Ensure brevity in your answer.  0.77. What is the ratio of the Rent(as % of GDP) of India in 2000 to that in 2002?
Make the answer very short. 0.92. What is the ratio of the Rent(as % of GDP) of Ukraine in 2000 to that in 2002?
Make the answer very short. 0.55. What is the ratio of the Rent(as % of GDP) in Georgia in 2000 to that in 2003?
Your answer should be compact. 0.5. What is the ratio of the Rent(as % of GDP) in India in 2000 to that in 2003?
Make the answer very short. 0.86. What is the ratio of the Rent(as % of GDP) of Ukraine in 2000 to that in 2003?
Your answer should be compact. 0.43. What is the ratio of the Rent(as % of GDP) in Finland in 2001 to that in 2002?
Keep it short and to the point. 0.83. What is the ratio of the Rent(as % of GDP) of Georgia in 2001 to that in 2002?
Make the answer very short. 0.5. What is the ratio of the Rent(as % of GDP) in Ukraine in 2001 to that in 2002?
Your answer should be very brief. 1.15. What is the ratio of the Rent(as % of GDP) in Finland in 2001 to that in 2003?
Offer a very short reply. 0.55. What is the ratio of the Rent(as % of GDP) in Georgia in 2001 to that in 2003?
Make the answer very short. 0.33. What is the ratio of the Rent(as % of GDP) of India in 2001 to that in 2003?
Offer a very short reply. 0.95. What is the ratio of the Rent(as % of GDP) in Ukraine in 2001 to that in 2003?
Offer a terse response. 0.91. What is the ratio of the Rent(as % of GDP) in Finland in 2002 to that in 2003?
Offer a terse response. 0.66. What is the ratio of the Rent(as % of GDP) in Georgia in 2002 to that in 2003?
Provide a succinct answer. 0.65. What is the ratio of the Rent(as % of GDP) in India in 2002 to that in 2003?
Make the answer very short. 0.94. What is the ratio of the Rent(as % of GDP) in Ukraine in 2002 to that in 2003?
Provide a succinct answer. 0.79. What is the difference between the highest and the second highest Rent(as % of GDP) of Finland?
Provide a short and direct response. 0. What is the difference between the highest and the second highest Rent(as % of GDP) in Georgia?
Offer a terse response. 0.1. What is the difference between the highest and the second highest Rent(as % of GDP) in India?
Your response must be concise. 0. What is the difference between the highest and the second highest Rent(as % of GDP) in Ukraine?
Provide a short and direct response. 0.05. What is the difference between the highest and the lowest Rent(as % of GDP) in Finland?
Provide a succinct answer. 0.01. What is the difference between the highest and the lowest Rent(as % of GDP) of Georgia?
Offer a terse response. 0.23. What is the difference between the highest and the lowest Rent(as % of GDP) of India?
Give a very brief answer. 0.14. What is the difference between the highest and the lowest Rent(as % of GDP) of Ukraine?
Your response must be concise. 0.55. 